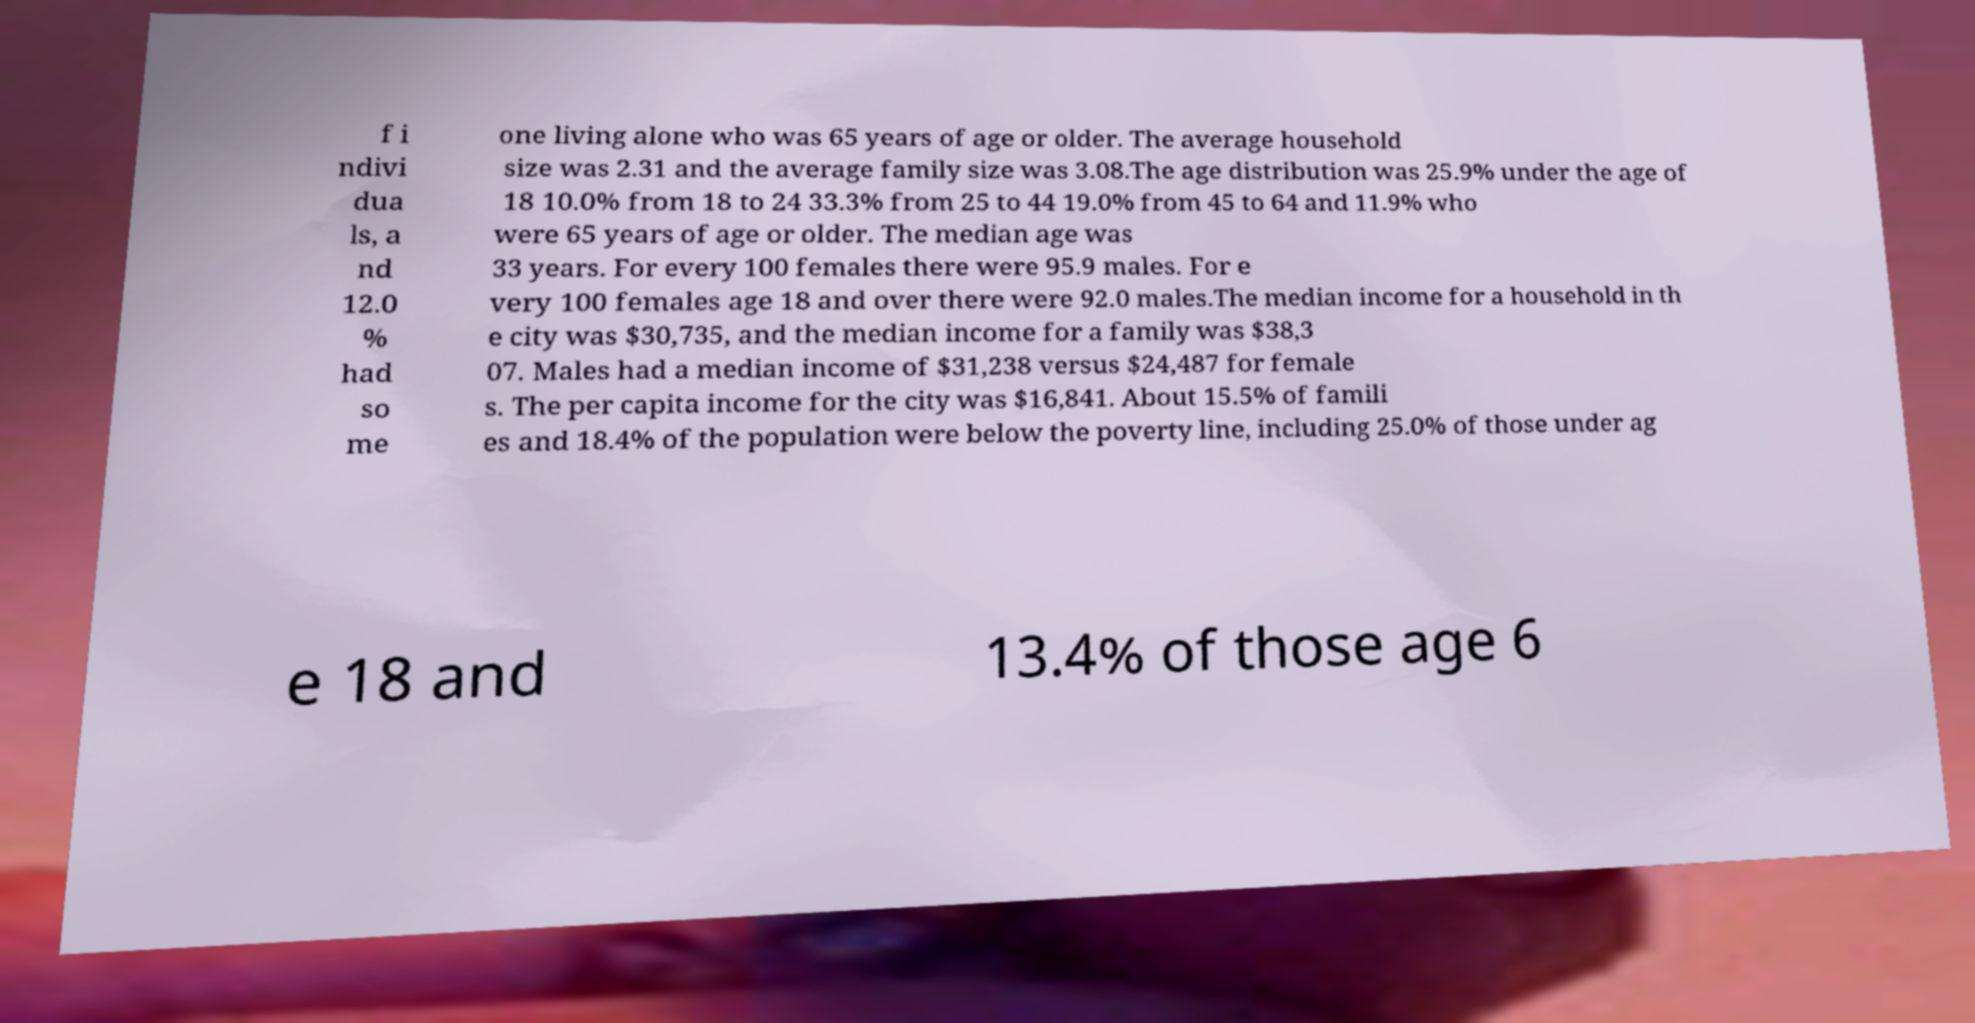I need the written content from this picture converted into text. Can you do that? f i ndivi dua ls, a nd 12.0 % had so me one living alone who was 65 years of age or older. The average household size was 2.31 and the average family size was 3.08.The age distribution was 25.9% under the age of 18 10.0% from 18 to 24 33.3% from 25 to 44 19.0% from 45 to 64 and 11.9% who were 65 years of age or older. The median age was 33 years. For every 100 females there were 95.9 males. For e very 100 females age 18 and over there were 92.0 males.The median income for a household in th e city was $30,735, and the median income for a family was $38,3 07. Males had a median income of $31,238 versus $24,487 for female s. The per capita income for the city was $16,841. About 15.5% of famili es and 18.4% of the population were below the poverty line, including 25.0% of those under ag e 18 and 13.4% of those age 6 